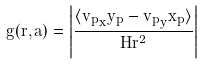<formula> <loc_0><loc_0><loc_500><loc_500>g ( r , a ) = \left | \frac { \langle { { v _ { p } } _ { x } y _ { p } - { v _ { p } } _ { y } x _ { p } } \rangle } { H r ^ { 2 } } \right |</formula> 